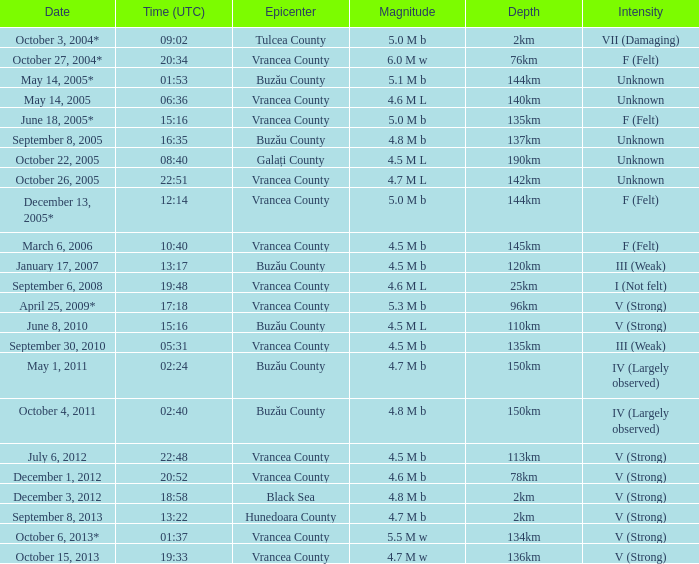Where was the epicenter of the quake on December 1, 2012? Vrancea County. 